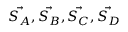Convert formula to latex. <formula><loc_0><loc_0><loc_500><loc_500>\vec { S _ { A } } , \vec { S _ { B } } , \vec { S _ { C } } , \vec { S _ { D } }</formula> 